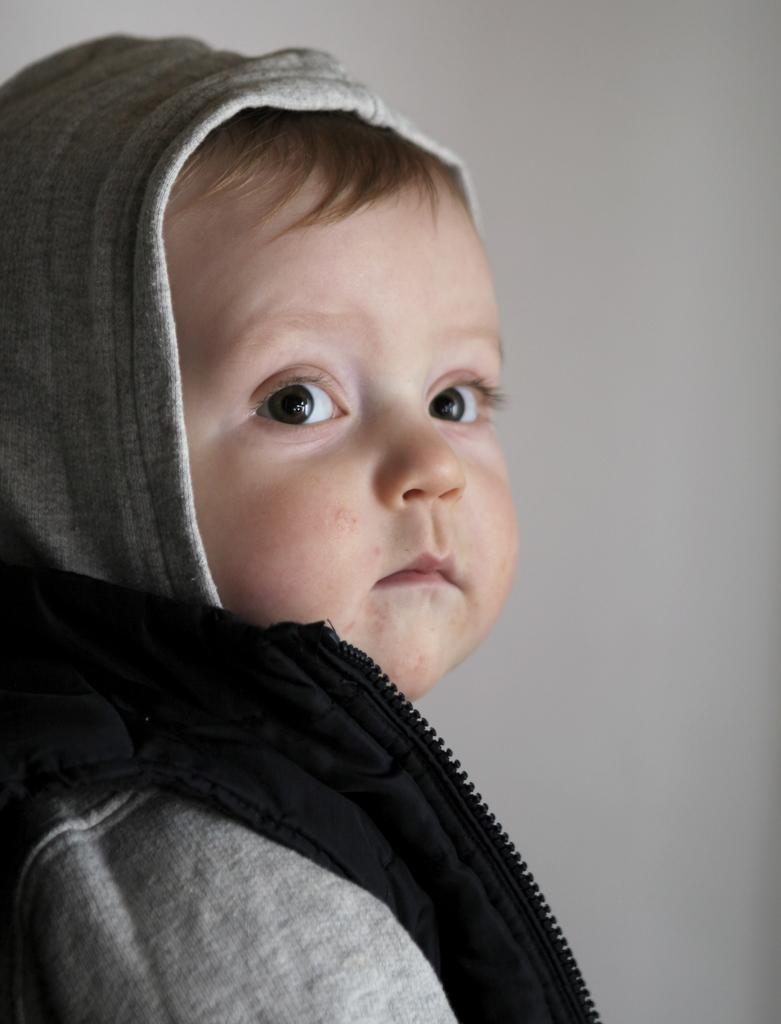Can you describe this image briefly? In this image I can see a child. The child is wearing a hoodie. 